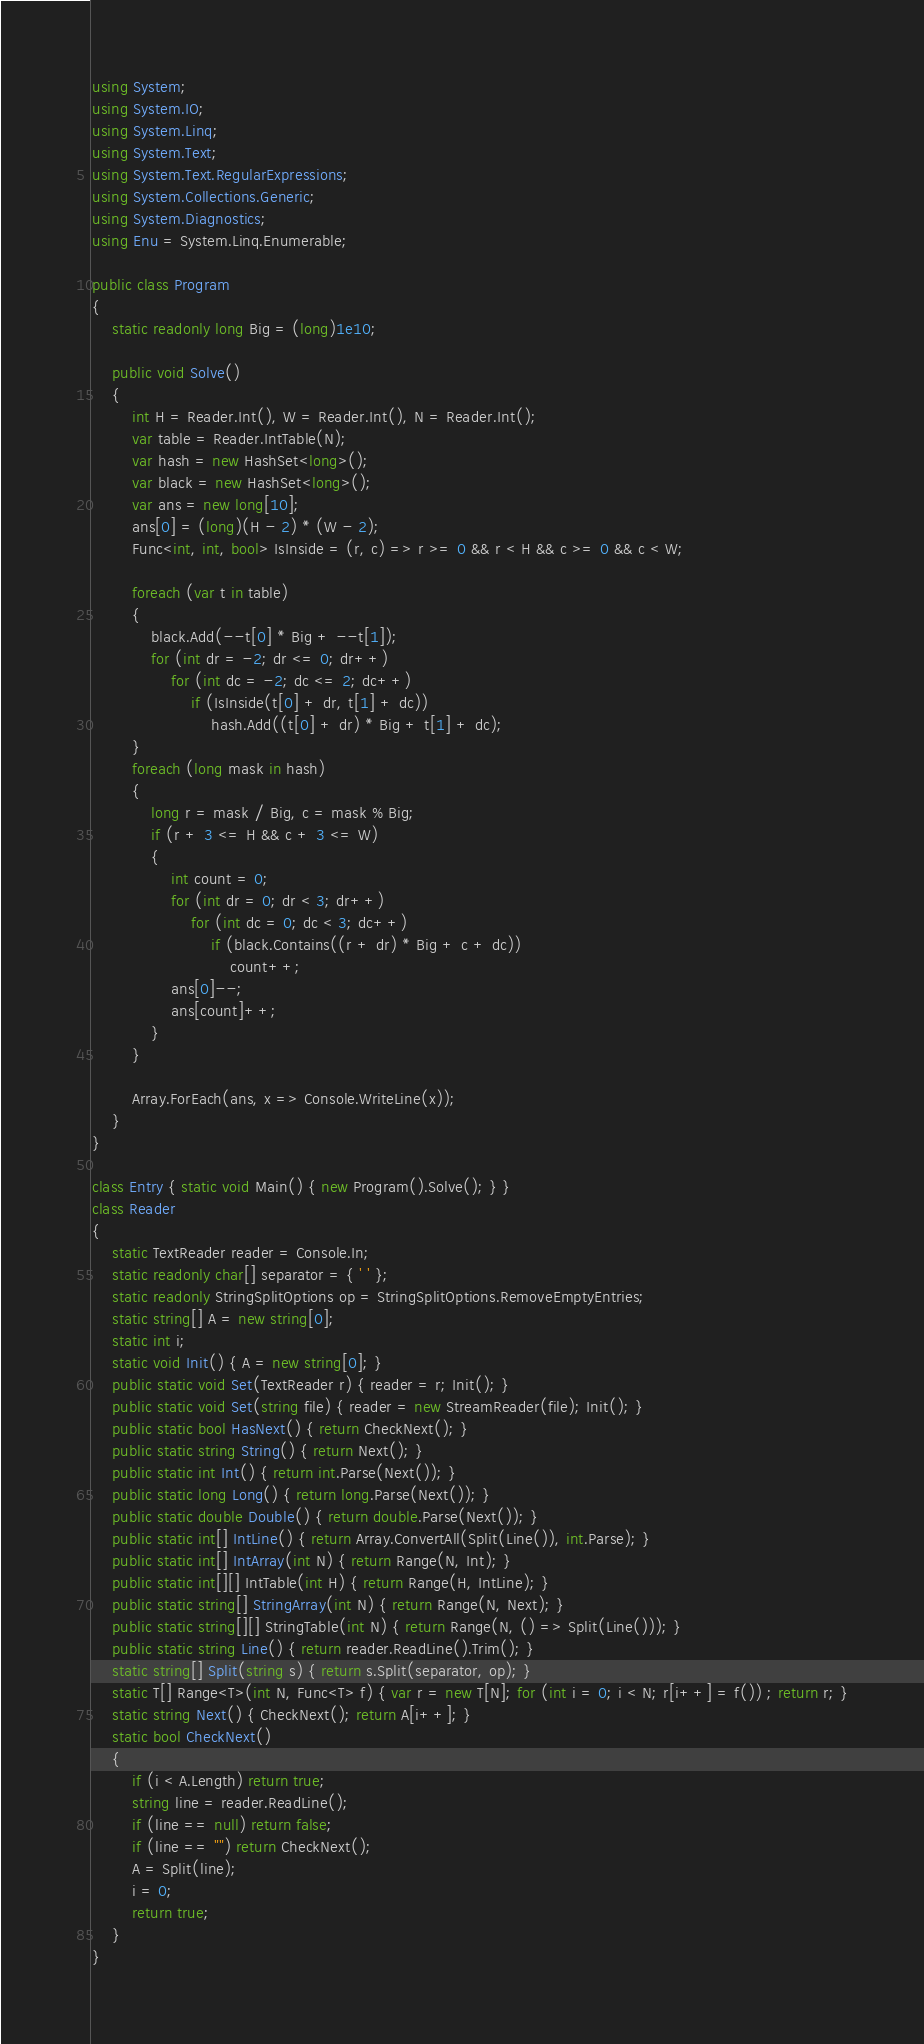<code> <loc_0><loc_0><loc_500><loc_500><_C#_>using System;
using System.IO;
using System.Linq;
using System.Text;
using System.Text.RegularExpressions;
using System.Collections.Generic;
using System.Diagnostics;
using Enu = System.Linq.Enumerable;

public class Program
{
    static readonly long Big = (long)1e10;

    public void Solve()
    {
        int H = Reader.Int(), W = Reader.Int(), N = Reader.Int();
        var table = Reader.IntTable(N);
        var hash = new HashSet<long>();
        var black = new HashSet<long>();
        var ans = new long[10];
        ans[0] = (long)(H - 2) * (W - 2);
        Func<int, int, bool> IsInside = (r, c) => r >= 0 && r < H && c >= 0 && c < W;

        foreach (var t in table)
        {
            black.Add(--t[0] * Big + --t[1]);
            for (int dr = -2; dr <= 0; dr++)
                for (int dc = -2; dc <= 2; dc++)
                    if (IsInside(t[0] + dr, t[1] + dc))
                        hash.Add((t[0] + dr) * Big + t[1] + dc);
        }
        foreach (long mask in hash)
        {
            long r = mask / Big, c = mask % Big;
            if (r + 3 <= H && c + 3 <= W)
            {
                int count = 0;
                for (int dr = 0; dr < 3; dr++)
                    for (int dc = 0; dc < 3; dc++)
                        if (black.Contains((r + dr) * Big + c + dc))
                            count++;
                ans[0]--;
                ans[count]++;
            }
        }

        Array.ForEach(ans, x => Console.WriteLine(x));
    }
}

class Entry { static void Main() { new Program().Solve(); } }
class Reader
{
    static TextReader reader = Console.In;
    static readonly char[] separator = { ' ' };
    static readonly StringSplitOptions op = StringSplitOptions.RemoveEmptyEntries;
    static string[] A = new string[0];
    static int i;
    static void Init() { A = new string[0]; }
    public static void Set(TextReader r) { reader = r; Init(); }
    public static void Set(string file) { reader = new StreamReader(file); Init(); }
    public static bool HasNext() { return CheckNext(); }
    public static string String() { return Next(); }
    public static int Int() { return int.Parse(Next()); }
    public static long Long() { return long.Parse(Next()); }
    public static double Double() { return double.Parse(Next()); }
    public static int[] IntLine() { return Array.ConvertAll(Split(Line()), int.Parse); }
    public static int[] IntArray(int N) { return Range(N, Int); }
    public static int[][] IntTable(int H) { return Range(H, IntLine); }
    public static string[] StringArray(int N) { return Range(N, Next); }
    public static string[][] StringTable(int N) { return Range(N, () => Split(Line())); }
    public static string Line() { return reader.ReadLine().Trim(); }
    static string[] Split(string s) { return s.Split(separator, op); }
    static T[] Range<T>(int N, Func<T> f) { var r = new T[N]; for (int i = 0; i < N; r[i++] = f()) ; return r; }
    static string Next() { CheckNext(); return A[i++]; }
    static bool CheckNext()
    {
        if (i < A.Length) return true;
        string line = reader.ReadLine();
        if (line == null) return false;
        if (line == "") return CheckNext();
        A = Split(line);
        i = 0;
        return true;
    }
}</code> 